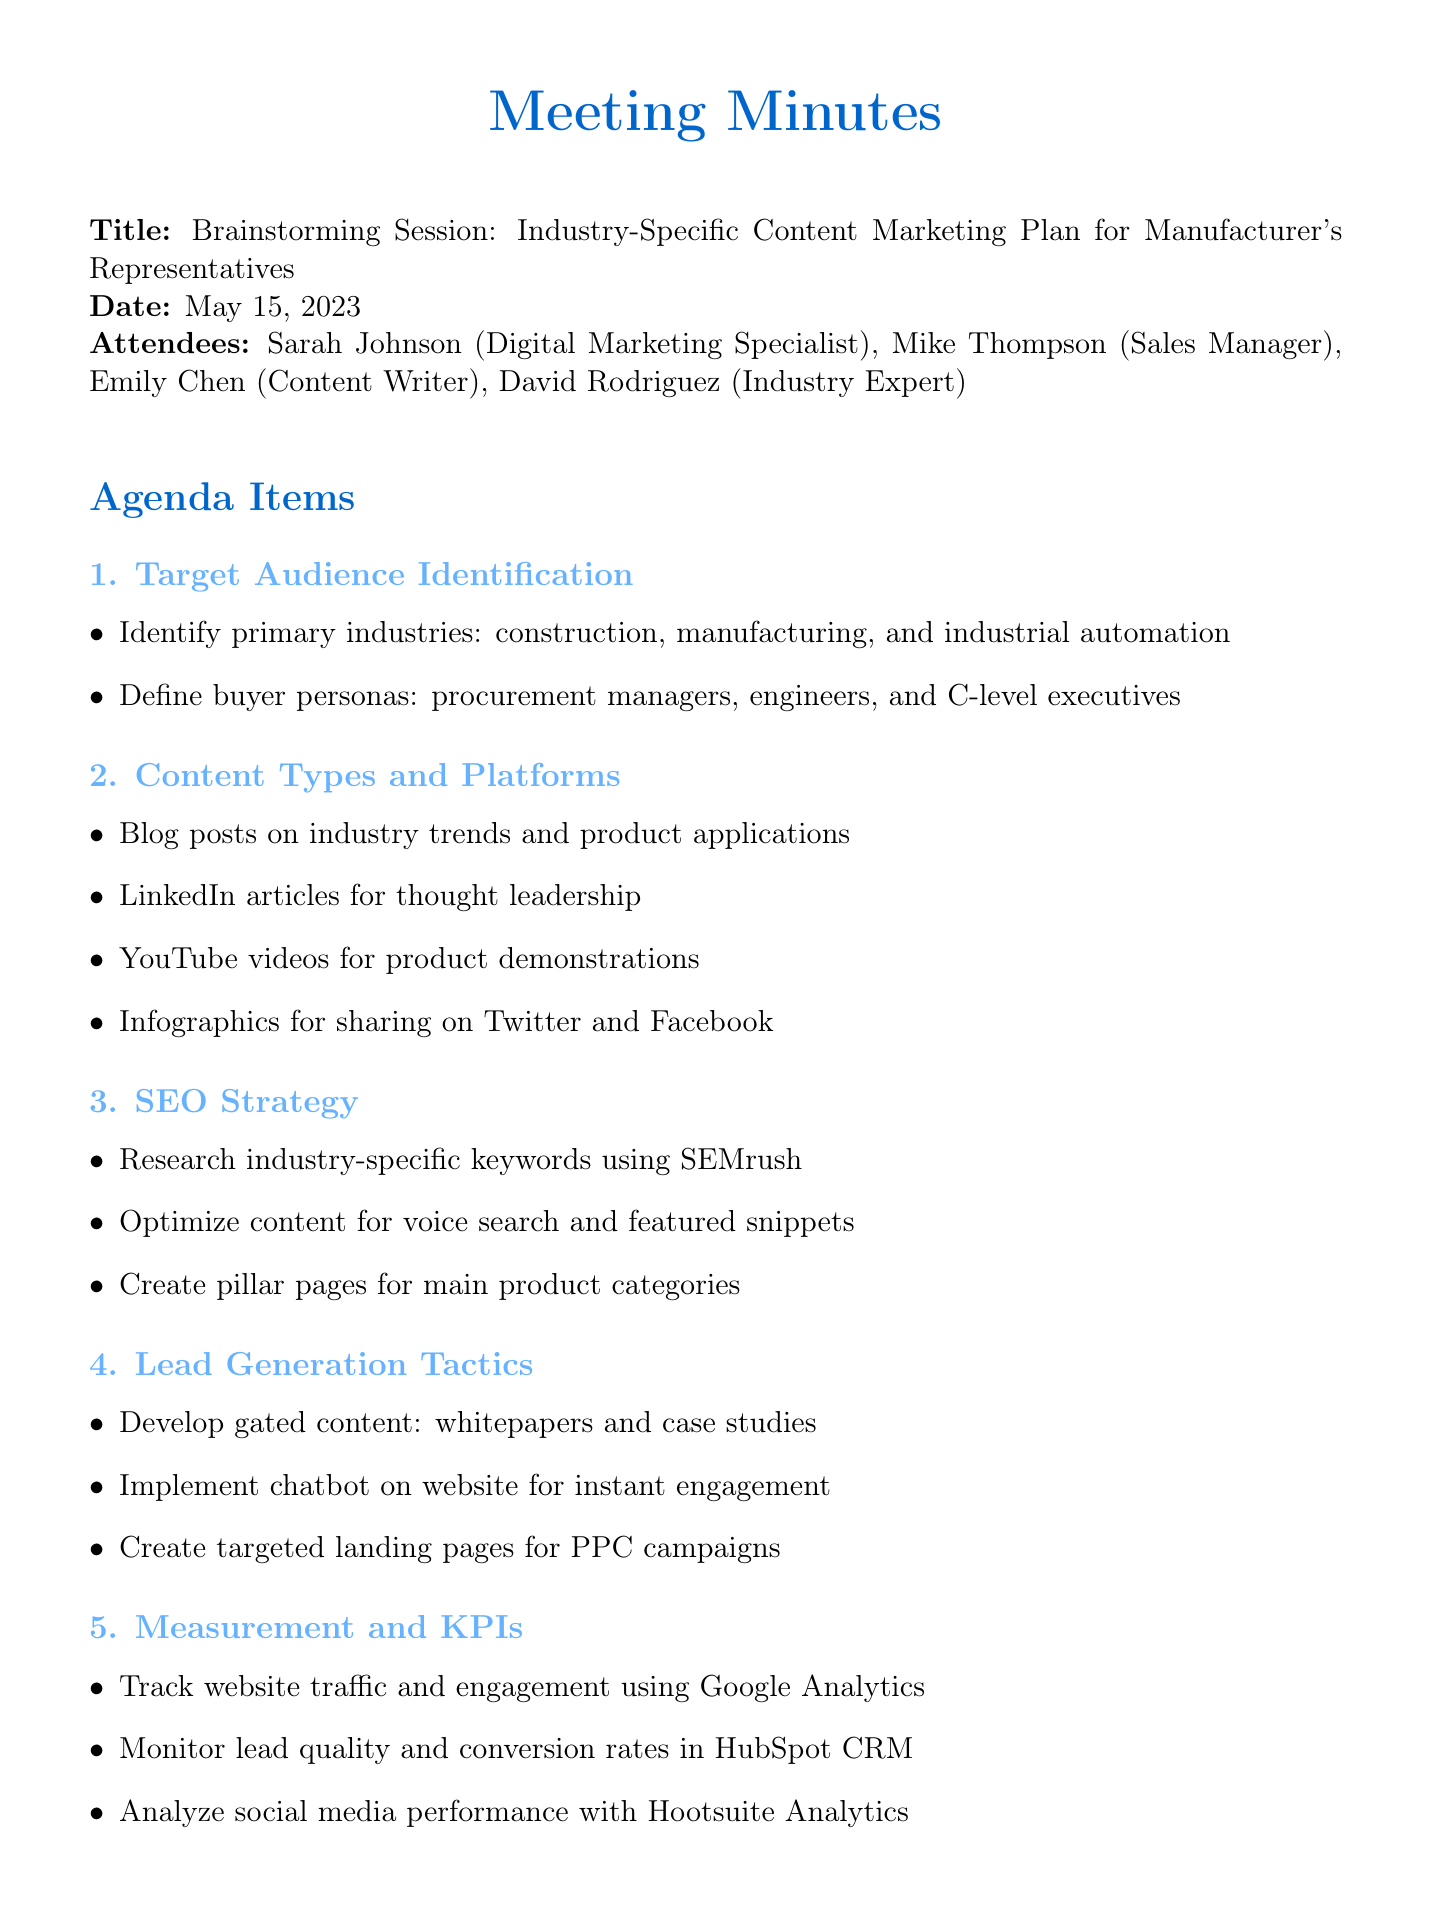What is the date of the meeting? The date of the meeting is explicitly mentioned in the document.
Answer: May 15, 2023 Who is the Digital Marketing Specialist attending the meeting? The document lists all attendees and their roles.
Answer: Sarah Johnson What is one of the primary industries identified? The primary industries were specified during the target audience identification.
Answer: Construction What type of content is suggested for thought leadership? The content types were discussed in detail, specifically for thought leadership.
Answer: LinkedIn articles What is one lead generation tactic mentioned? The document outlines various lead generation tactics.
Answer: Gated content How many attendees were present at the meeting? The number of attendees is provided in the attendee list.
Answer: Four What is the next meeting date? The document specifies the date for the next meeting.
Answer: May 29, 2023 Who is tasked with creating the content calendar for Q3? The action items assign specific tasks to attendees.
Answer: Emily What tool is recommended for researching industry-specific keywords? The SEO strategy mentions a tool for keyword research.
Answer: SEMrush 